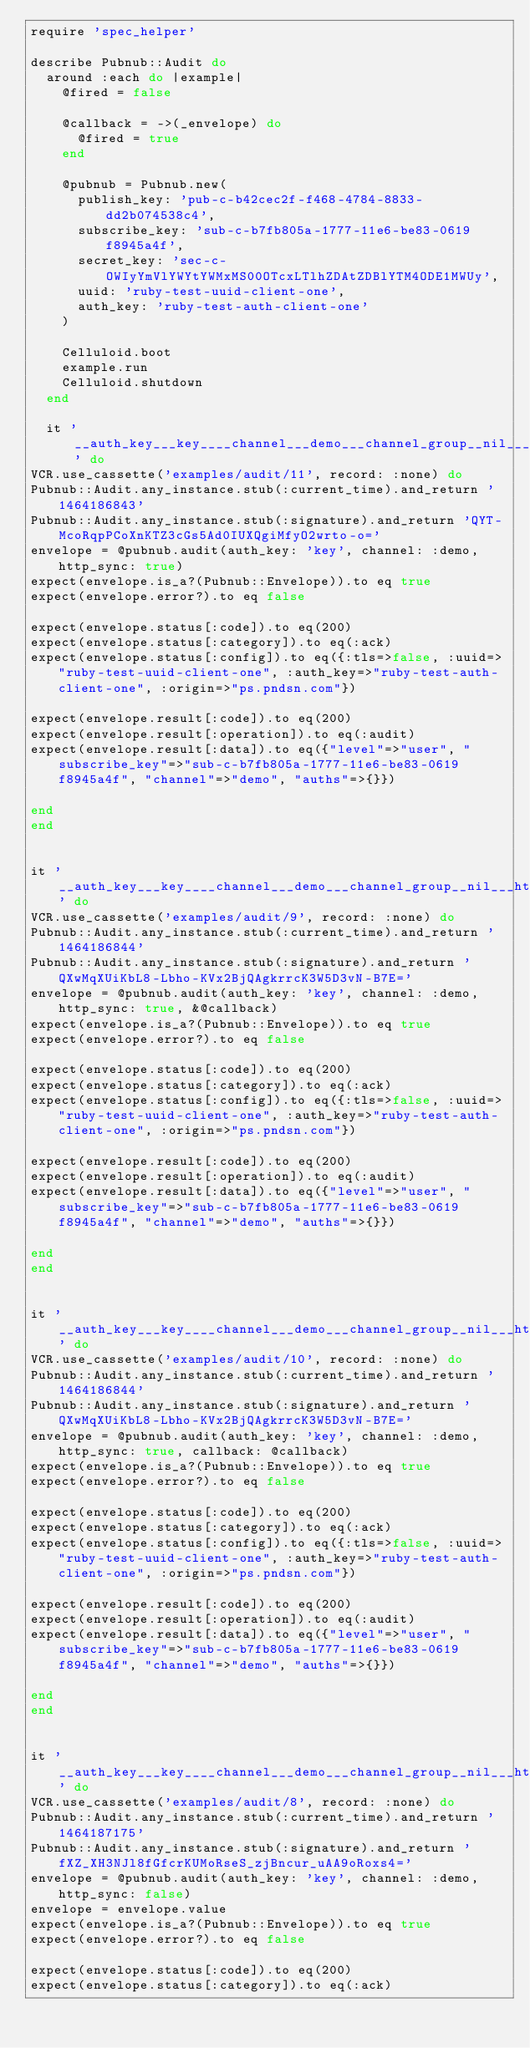<code> <loc_0><loc_0><loc_500><loc_500><_Ruby_>require 'spec_helper'

describe Pubnub::Audit do
  around :each do |example|
    @fired = false

    @callback = ->(_envelope) do
      @fired = true
    end

    @pubnub = Pubnub.new(
      publish_key: 'pub-c-b42cec2f-f468-4784-8833-dd2b074538c4',
      subscribe_key: 'sub-c-b7fb805a-1777-11e6-be83-0619f8945a4f',
      secret_key: 'sec-c-OWIyYmVlYWYtYWMxMS00OTcxLTlhZDAtZDBlYTM4ODE1MWUy',
      uuid: 'ruby-test-uuid-client-one',
      auth_key: 'ruby-test-auth-client-one'
    )

    Celluloid.boot
    example.run
    Celluloid.shutdown
  end

  it '__auth_key___key____channel___demo___channel_group__nil___http_sync__true___callback__nil_' do
VCR.use_cassette('examples/audit/11', record: :none) do
Pubnub::Audit.any_instance.stub(:current_time).and_return '1464186843'
Pubnub::Audit.any_instance.stub(:signature).and_return 'QYT-McoRqpPCoXnKTZ3cGs5Ad0IUXQgiMfyO2wrto-o='
envelope = @pubnub.audit(auth_key: 'key', channel: :demo, http_sync: true)
expect(envelope.is_a?(Pubnub::Envelope)).to eq true
expect(envelope.error?).to eq false

expect(envelope.status[:code]).to eq(200)
expect(envelope.status[:category]).to eq(:ack)
expect(envelope.status[:config]).to eq({:tls=>false, :uuid=>"ruby-test-uuid-client-one", :auth_key=>"ruby-test-auth-client-one", :origin=>"ps.pndsn.com"})

expect(envelope.result[:code]).to eq(200)
expect(envelope.result[:operation]).to eq(:audit)
expect(envelope.result[:data]).to eq({"level"=>"user", "subscribe_key"=>"sub-c-b7fb805a-1777-11e6-be83-0619f8945a4f", "channel"=>"demo", "auths"=>{}})

end
end


it '__auth_key___key____channel___demo___channel_group__nil___http_sync__true___callback___block_' do
VCR.use_cassette('examples/audit/9', record: :none) do
Pubnub::Audit.any_instance.stub(:current_time).and_return '1464186844'
Pubnub::Audit.any_instance.stub(:signature).and_return 'QXwMqXUiKbL8-Lbho-KVx2BjQAgkrrcK3W5D3vN-B7E='
envelope = @pubnub.audit(auth_key: 'key', channel: :demo, http_sync: true, &@callback)
expect(envelope.is_a?(Pubnub::Envelope)).to eq true
expect(envelope.error?).to eq false

expect(envelope.status[:code]).to eq(200)
expect(envelope.status[:category]).to eq(:ack)
expect(envelope.status[:config]).to eq({:tls=>false, :uuid=>"ruby-test-uuid-client-one", :auth_key=>"ruby-test-auth-client-one", :origin=>"ps.pndsn.com"})

expect(envelope.result[:code]).to eq(200)
expect(envelope.result[:operation]).to eq(:audit)
expect(envelope.result[:data]).to eq({"level"=>"user", "subscribe_key"=>"sub-c-b7fb805a-1777-11e6-be83-0619f8945a4f", "channel"=>"demo", "auths"=>{}})

end
end


it '__auth_key___key____channel___demo___channel_group__nil___http_sync__true___callback___lambda_' do
VCR.use_cassette('examples/audit/10', record: :none) do
Pubnub::Audit.any_instance.stub(:current_time).and_return '1464186844'
Pubnub::Audit.any_instance.stub(:signature).and_return 'QXwMqXUiKbL8-Lbho-KVx2BjQAgkrrcK3W5D3vN-B7E='
envelope = @pubnub.audit(auth_key: 'key', channel: :demo, http_sync: true, callback: @callback)
expect(envelope.is_a?(Pubnub::Envelope)).to eq true
expect(envelope.error?).to eq false

expect(envelope.status[:code]).to eq(200)
expect(envelope.status[:category]).to eq(:ack)
expect(envelope.status[:config]).to eq({:tls=>false, :uuid=>"ruby-test-uuid-client-one", :auth_key=>"ruby-test-auth-client-one", :origin=>"ps.pndsn.com"})

expect(envelope.result[:code]).to eq(200)
expect(envelope.result[:operation]).to eq(:audit)
expect(envelope.result[:data]).to eq({"level"=>"user", "subscribe_key"=>"sub-c-b7fb805a-1777-11e6-be83-0619f8945a4f", "channel"=>"demo", "auths"=>{}})

end
end


it '__auth_key___key____channel___demo___channel_group__nil___http_sync__false___callback__nil_' do
VCR.use_cassette('examples/audit/8', record: :none) do
Pubnub::Audit.any_instance.stub(:current_time).and_return '1464187175'
Pubnub::Audit.any_instance.stub(:signature).and_return 'fXZ_XH3NJl8fGfcrKUMoRseS_zjBncur_uAA9oRoxs4='
envelope = @pubnub.audit(auth_key: 'key', channel: :demo, http_sync: false)
envelope = envelope.value
expect(envelope.is_a?(Pubnub::Envelope)).to eq true
expect(envelope.error?).to eq false

expect(envelope.status[:code]).to eq(200)
expect(envelope.status[:category]).to eq(:ack)</code> 